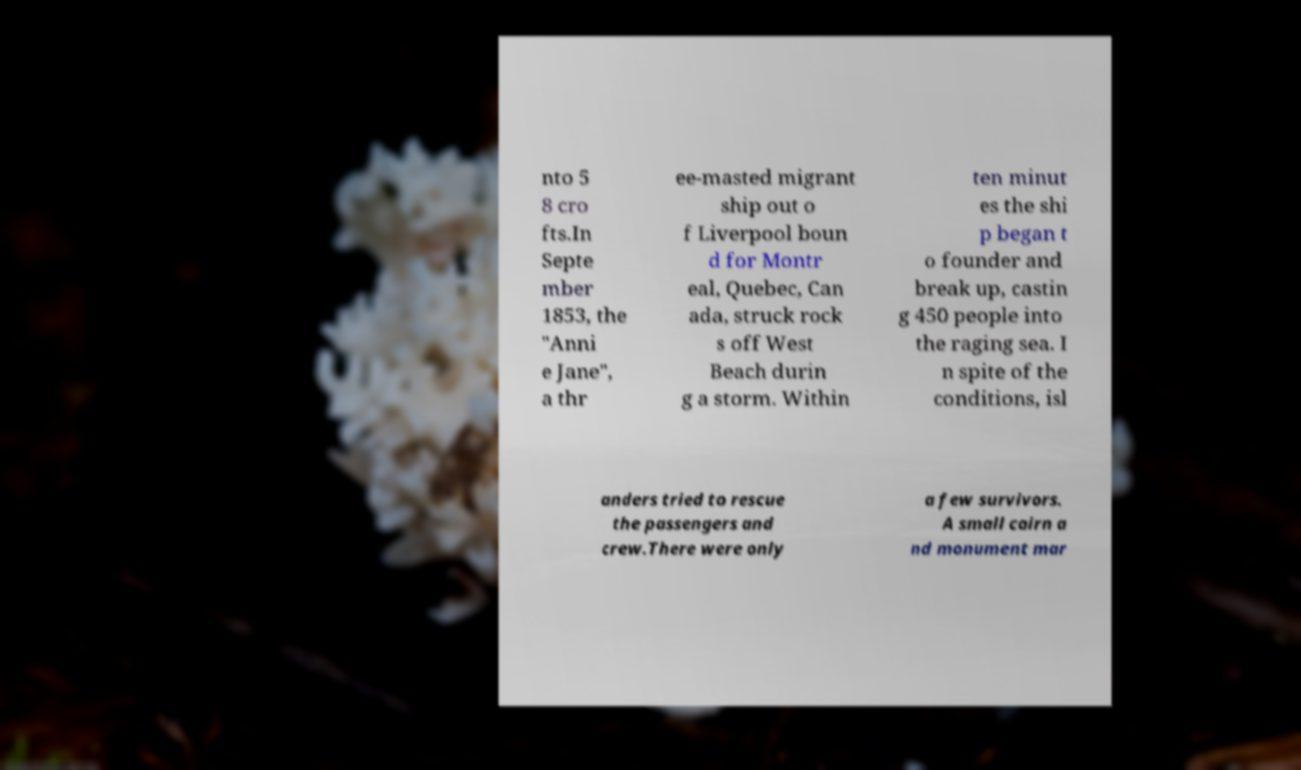Can you accurately transcribe the text from the provided image for me? nto 5 8 cro fts.In Septe mber 1853, the "Anni e Jane", a thr ee-masted migrant ship out o f Liverpool boun d for Montr eal, Quebec, Can ada, struck rock s off West Beach durin g a storm. Within ten minut es the shi p began t o founder and break up, castin g 450 people into the raging sea. I n spite of the conditions, isl anders tried to rescue the passengers and crew.There were only a few survivors. A small cairn a nd monument mar 